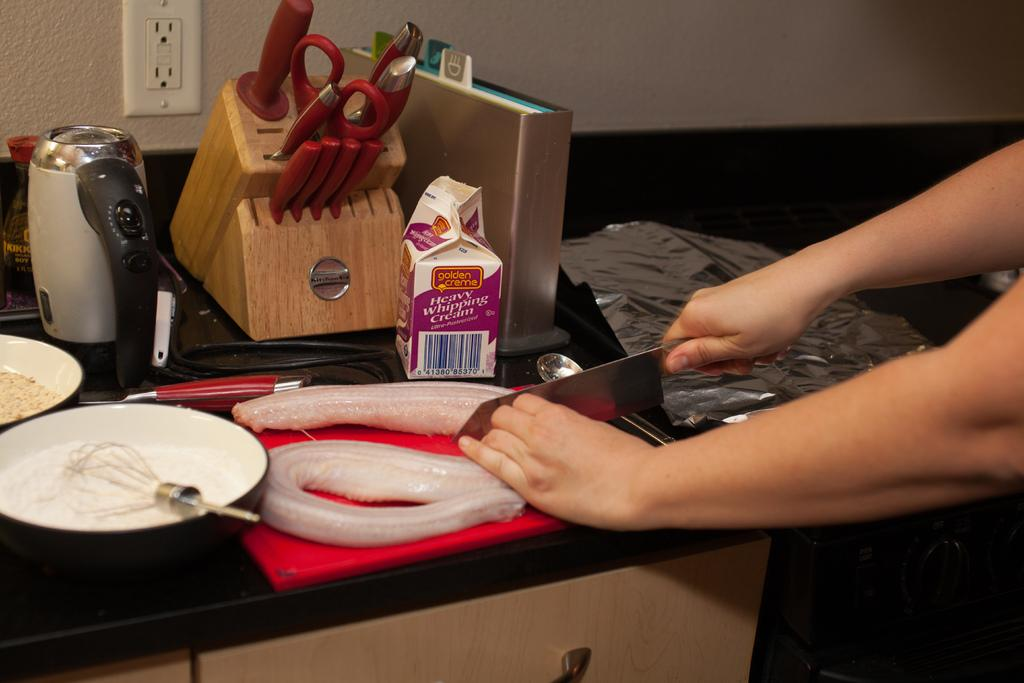<image>
Summarize the visual content of the image. Person using a knife next to a carton that says Heavy Whipping Cream. 